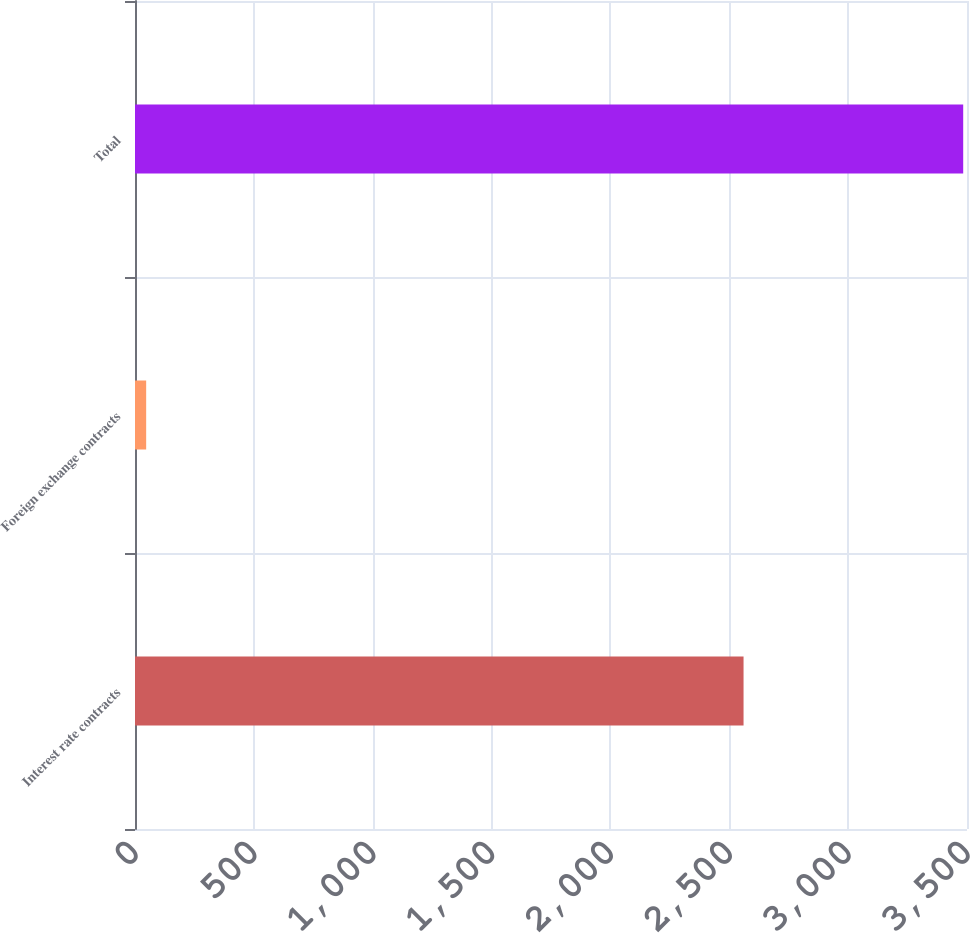Convert chart to OTSL. <chart><loc_0><loc_0><loc_500><loc_500><bar_chart><fcel>Interest rate contracts<fcel>Foreign exchange contracts<fcel>Total<nl><fcel>2560<fcel>47<fcel>3484<nl></chart> 